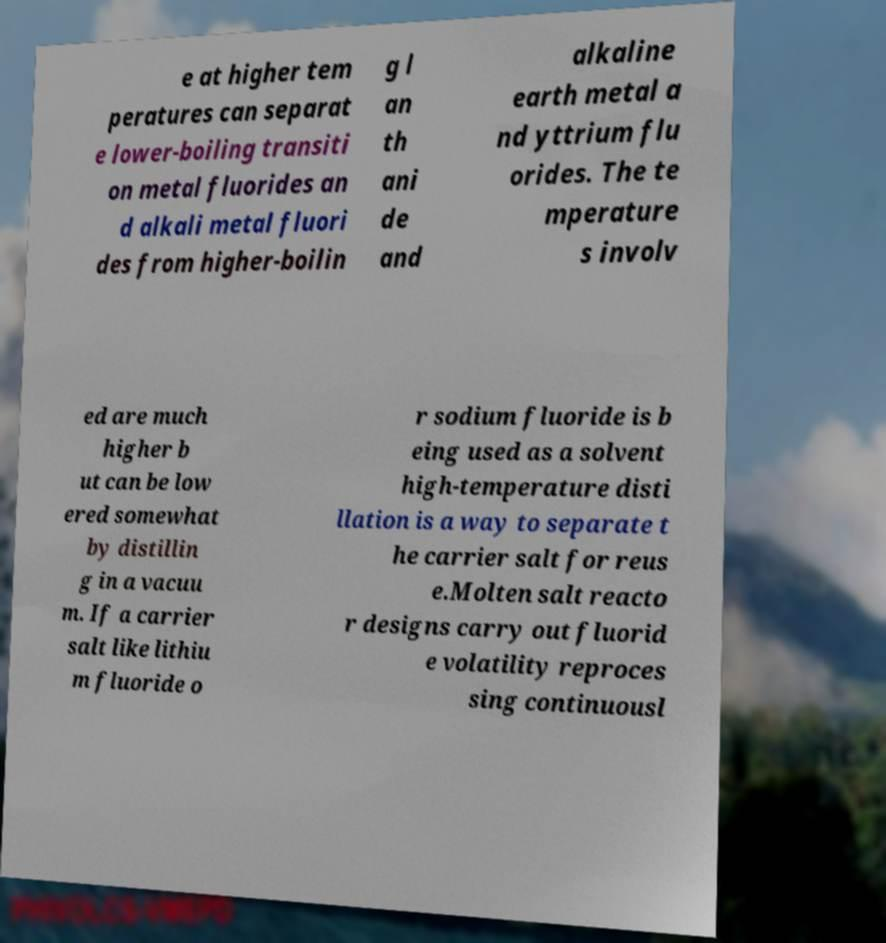There's text embedded in this image that I need extracted. Can you transcribe it verbatim? e at higher tem peratures can separat e lower-boiling transiti on metal fluorides an d alkali metal fluori des from higher-boilin g l an th ani de and alkaline earth metal a nd yttrium flu orides. The te mperature s involv ed are much higher b ut can be low ered somewhat by distillin g in a vacuu m. If a carrier salt like lithiu m fluoride o r sodium fluoride is b eing used as a solvent high-temperature disti llation is a way to separate t he carrier salt for reus e.Molten salt reacto r designs carry out fluorid e volatility reproces sing continuousl 